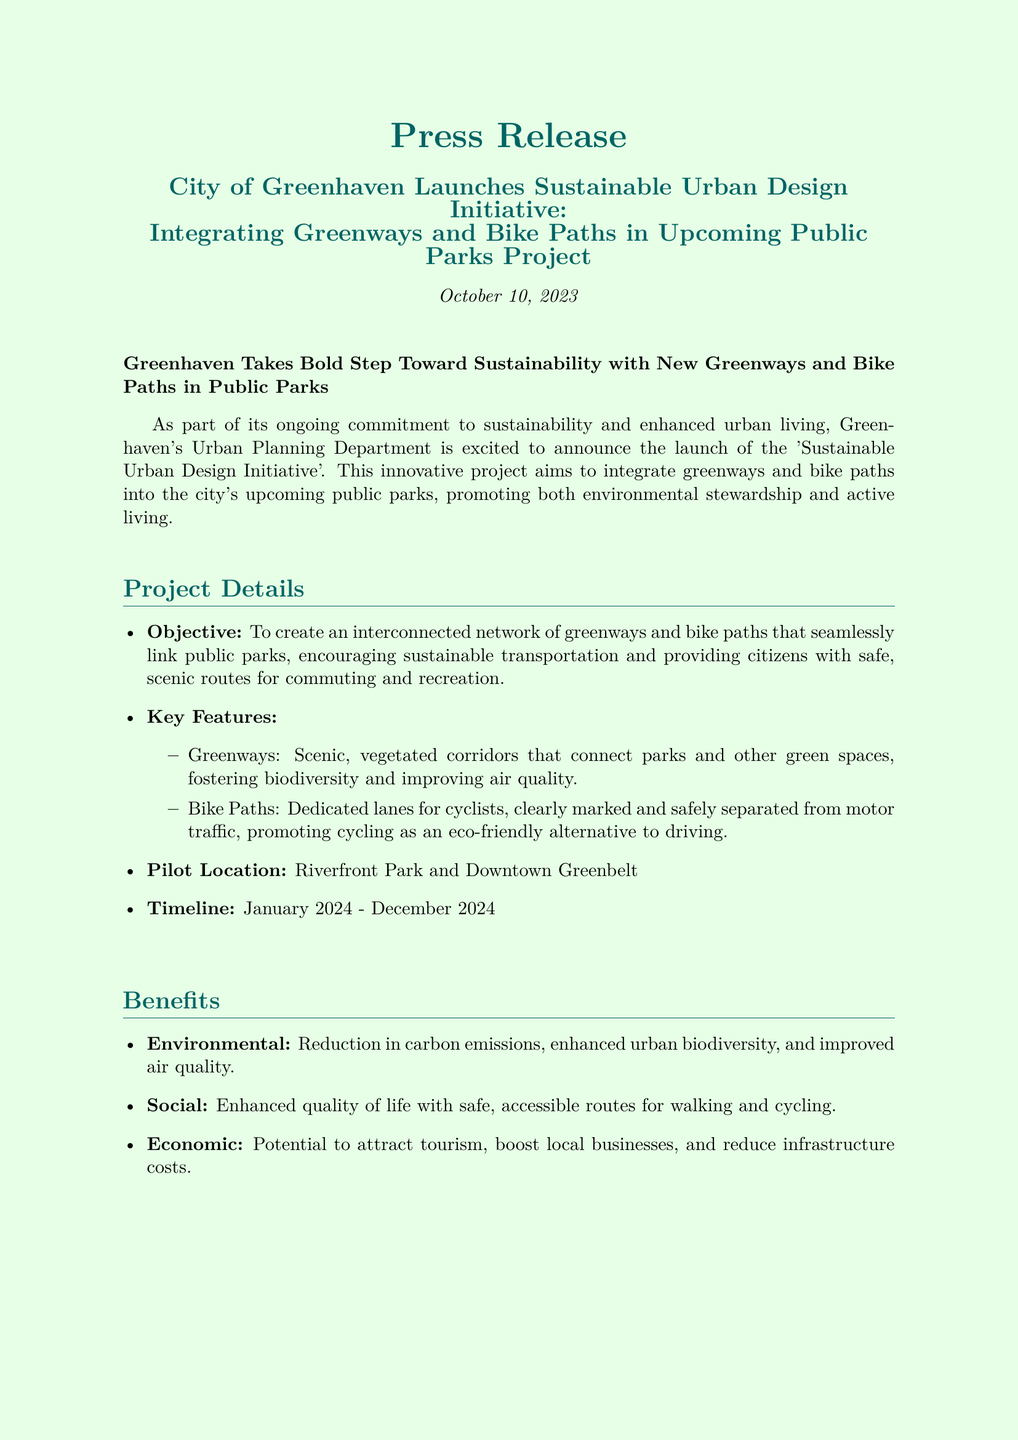What is the objective of the initiative? The objective is to create an interconnected network of greenways and bike paths that seamlessly link public parks.
Answer: To create an interconnected network of greenways and bike paths What are the key features of the project? The key features include greenways and bike paths.
Answer: Greenways and bike paths When is the project timeline? The timeline states that the project will run from January 2024 to December 2024.
Answer: January 2024 - December 2024 Which locations will the pilot project be implemented? The pilot locations specified in the document are Riverfront Park and Downtown Greenbelt.
Answer: Riverfront Park and Downtown Greenbelt What is one environmental benefit mentioned? The document lists reduction in carbon emissions as an environmental benefit.
Answer: Reduction in carbon emissions What is the call to action for citizens? Citizens are encouraged to participate in public forums and provide feedback on the proposed greenways and bike paths.
Answer: Participate in public forums What quote expresses the project's significance? The quote by Jane Smith emphasizes building a greener, healthier future for Greenhaven.
Answer: Building a greener, healthier future for Greenhaven What department is behind the initiative? The department mentioned as responsible for the initiative is the Urban Planning Department.
Answer: Urban Planning Department Who is the contact person for more information? Alex Johnson is named as the contact person in the press release.
Answer: Alex Johnson 